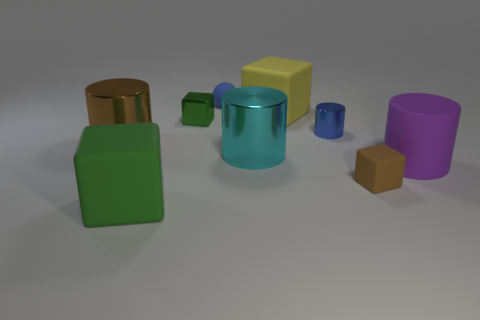Is there another tiny matte ball that has the same color as the sphere?
Your response must be concise. No. How many blue things are left of the blue matte object?
Your answer should be very brief. 0. What number of other things are the same size as the ball?
Give a very brief answer. 3. Does the brown object on the right side of the tiny blue cylinder have the same material as the small block on the left side of the brown rubber object?
Keep it short and to the point. No. What is the color of the rubber ball that is the same size as the green shiny block?
Give a very brief answer. Blue. Is there any other thing that is the same color as the large rubber cylinder?
Your answer should be very brief. No. There is a rubber block behind the cylinder to the right of the tiny rubber thing that is to the right of the yellow cube; what is its size?
Offer a very short reply. Large. There is a large object that is on the left side of the cyan metal cylinder and behind the big cyan metallic cylinder; what is its color?
Offer a terse response. Brown. How big is the brown object in front of the brown metal cylinder?
Your answer should be compact. Small. What number of yellow things have the same material as the cyan object?
Provide a short and direct response. 0. 